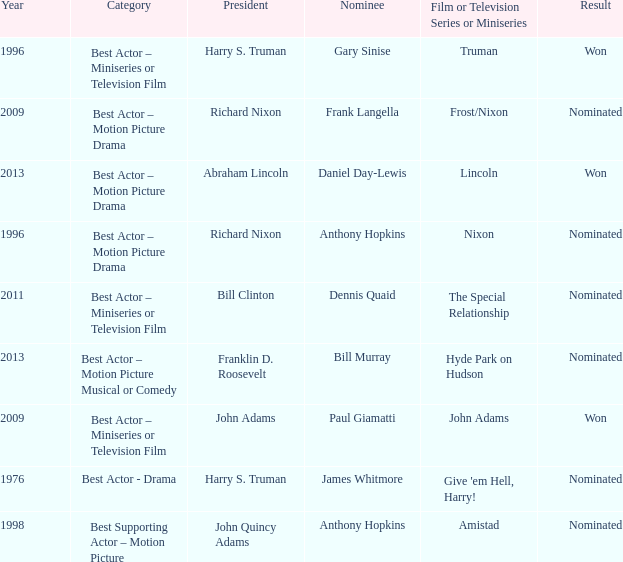What was the result of Frank Langella? Nominated. 